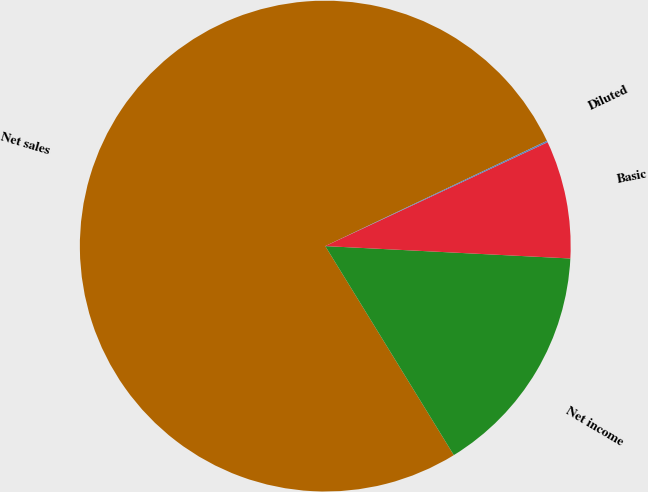<chart> <loc_0><loc_0><loc_500><loc_500><pie_chart><fcel>Net sales<fcel>Net income<fcel>Basic<fcel>Diluted<nl><fcel>76.72%<fcel>15.42%<fcel>7.76%<fcel>0.1%<nl></chart> 